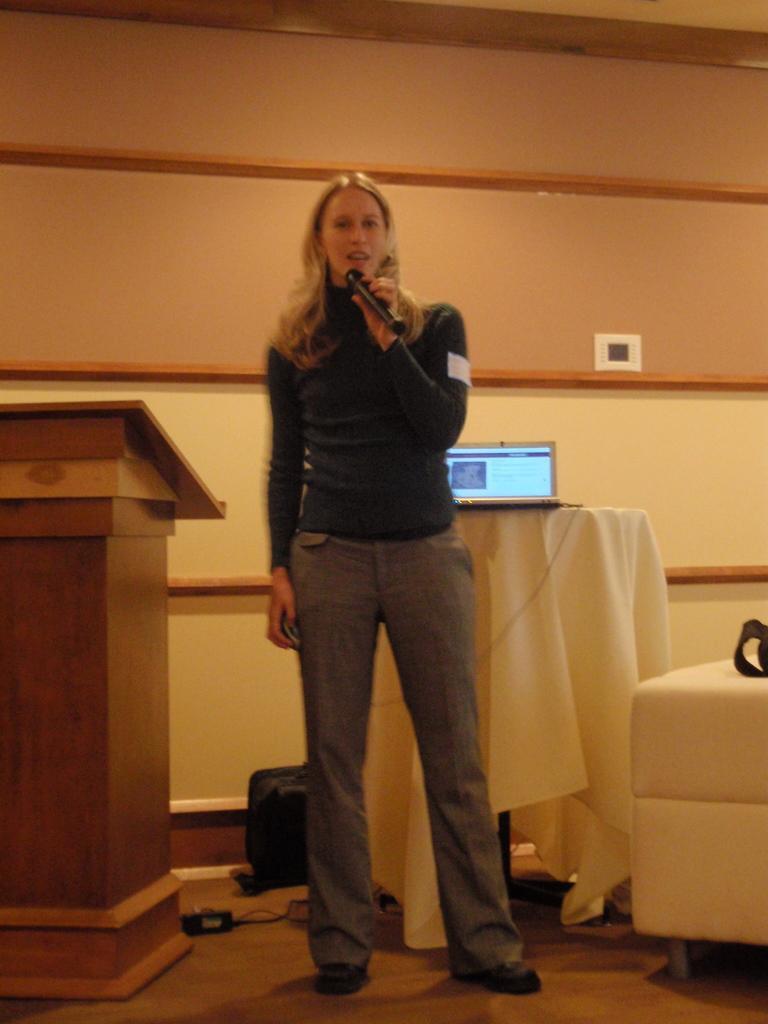Can you describe this image briefly? In this picture we can see a woman is holding a microphone and she is standing on the floor. On the left side of the woman there is a podium. On the right side of the woman, it looks like a chair. Behind the woman there is a table, which is covered by a cloth and on the table there is a laptop. Behind the table there is a wall. On the floor there is an adapter, cable and an object. 